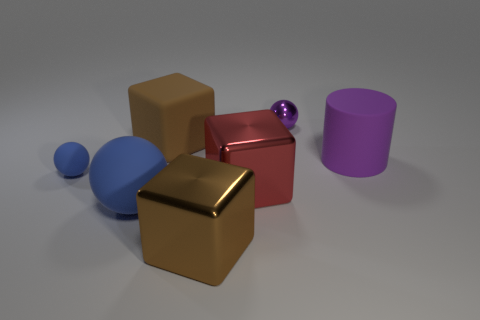How many objects are either tiny balls right of the tiny blue rubber thing or large things that are in front of the purple cylinder?
Make the answer very short. 4. There is a ball that is both to the right of the tiny blue ball and behind the large red shiny block; what is its color?
Your answer should be very brief. Purple. Are there more small brown metallic cubes than purple cylinders?
Ensure brevity in your answer.  No. Is the shape of the object behind the matte cube the same as  the large purple rubber thing?
Your answer should be very brief. No. How many metallic things are either large blue things or large purple objects?
Offer a very short reply. 0. Are there any other cubes that have the same material as the large red block?
Your response must be concise. Yes. What is the material of the cylinder?
Your answer should be very brief. Rubber. What is the shape of the tiny object that is to the right of the cube that is in front of the blue sphere in front of the big red thing?
Give a very brief answer. Sphere. Is the number of things that are right of the tiny purple metal thing greater than the number of tiny purple shiny things?
Your response must be concise. No. Is the shape of the large purple thing the same as the tiny thing that is on the right side of the big rubber block?
Ensure brevity in your answer.  No. 